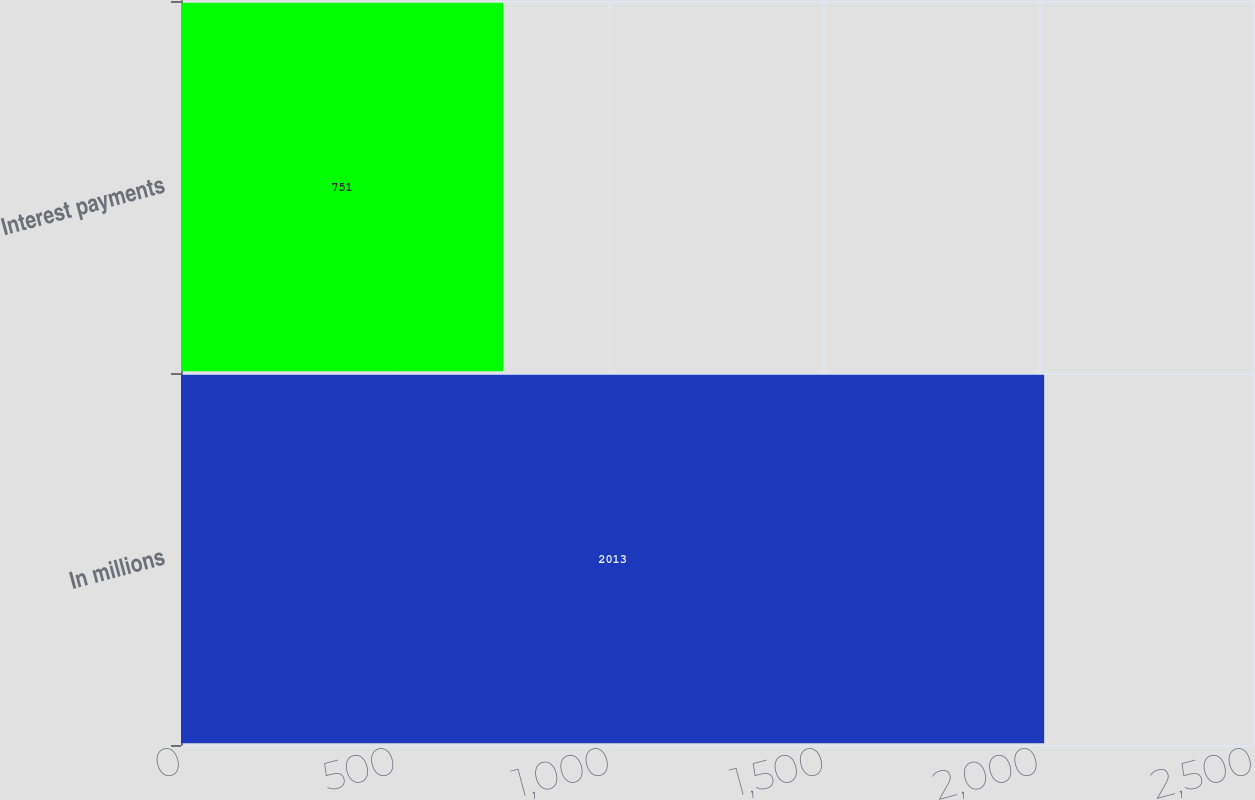<chart> <loc_0><loc_0><loc_500><loc_500><bar_chart><fcel>In millions<fcel>Interest payments<nl><fcel>2013<fcel>751<nl></chart> 